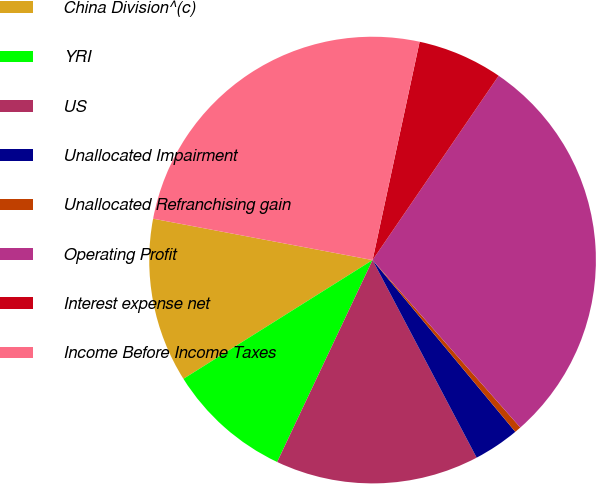Convert chart. <chart><loc_0><loc_0><loc_500><loc_500><pie_chart><fcel>China Division^(c)<fcel>YRI<fcel>US<fcel>Unallocated Impairment<fcel>Unallocated Refranchising gain<fcel>Operating Profit<fcel>Interest expense net<fcel>Income Before Income Taxes<nl><fcel>11.89%<fcel>9.05%<fcel>14.74%<fcel>3.32%<fcel>0.47%<fcel>28.94%<fcel>6.17%<fcel>25.41%<nl></chart> 